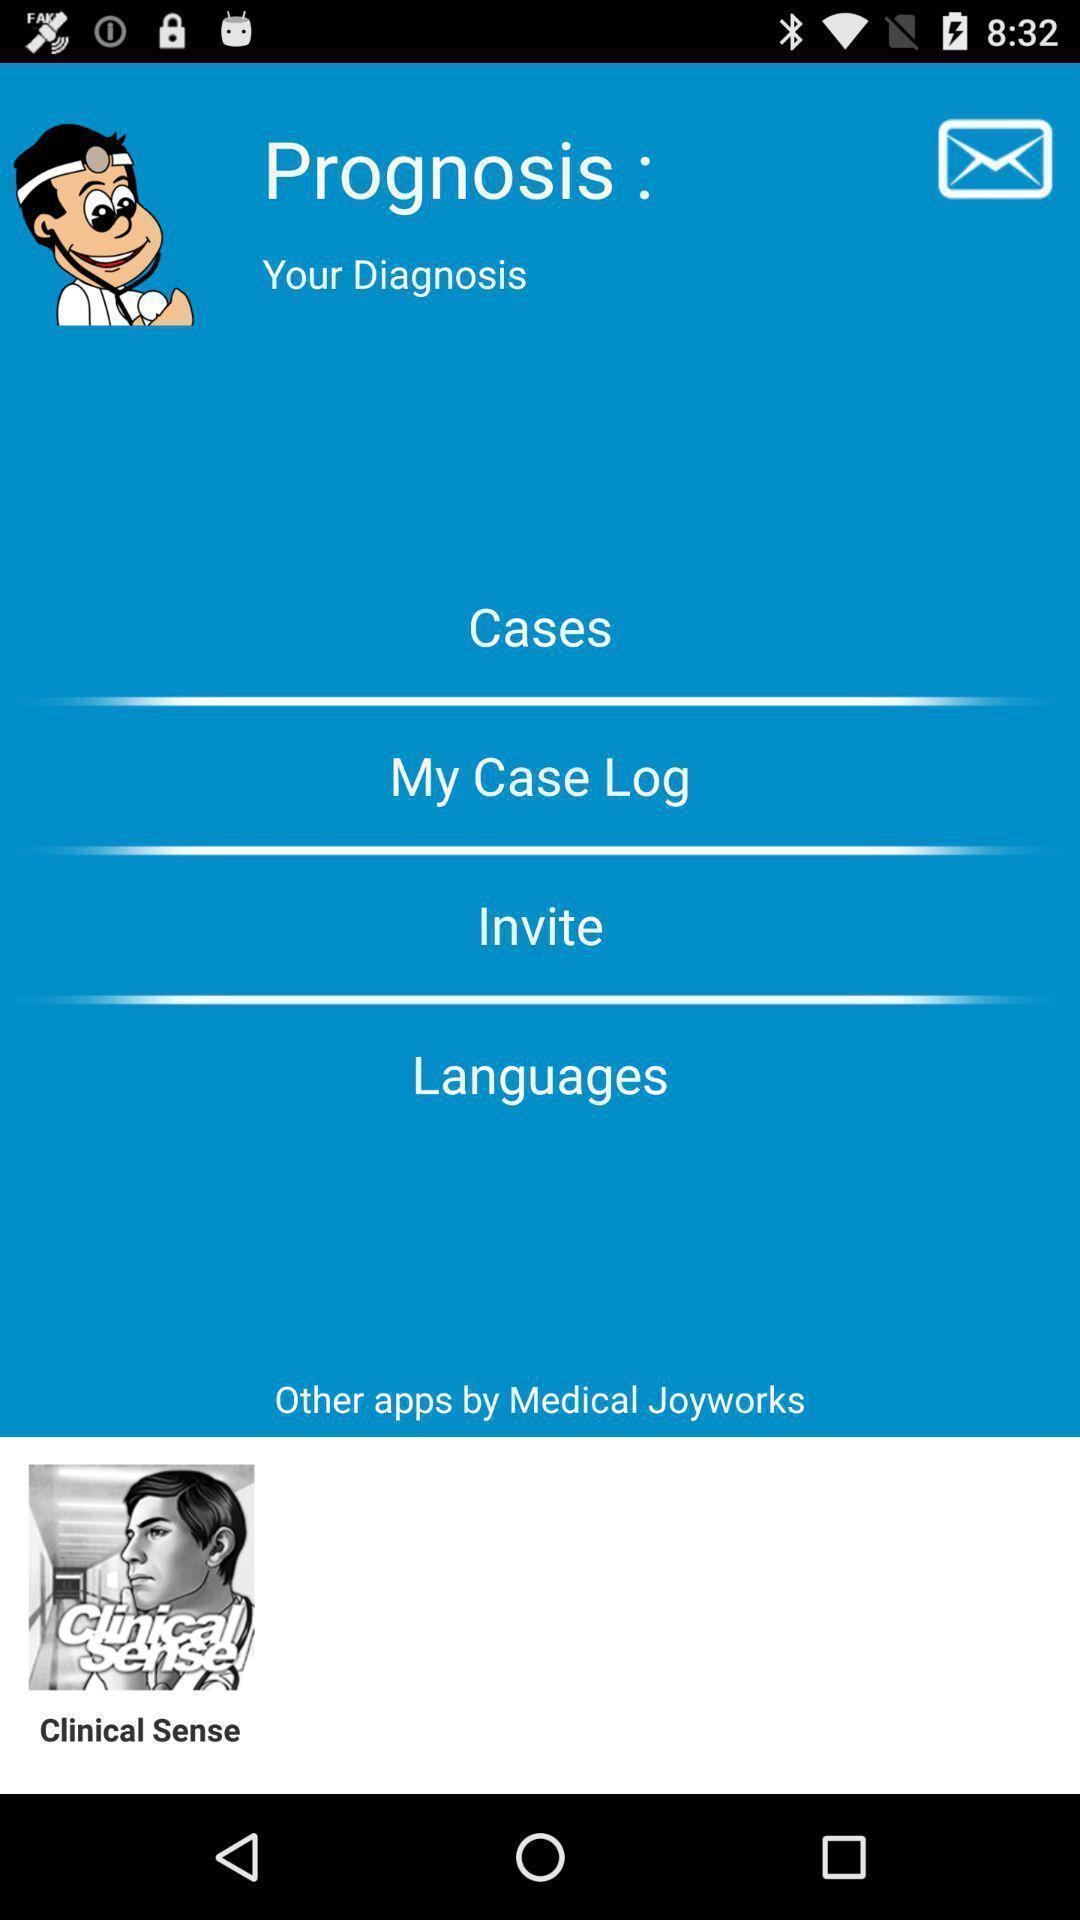Describe the content in this image. Welcome page displaying with options in an doctor app. 